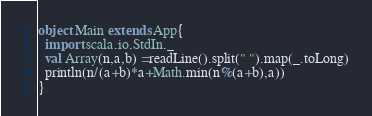<code> <loc_0><loc_0><loc_500><loc_500><_Scala_>object Main extends App{
  import scala.io.StdIn._
  val Array(n,a,b) =readLine().split(" ").map(_.toLong)
  println(n/(a+b)*a+Math.min(n%(a+b),a))
}
</code> 